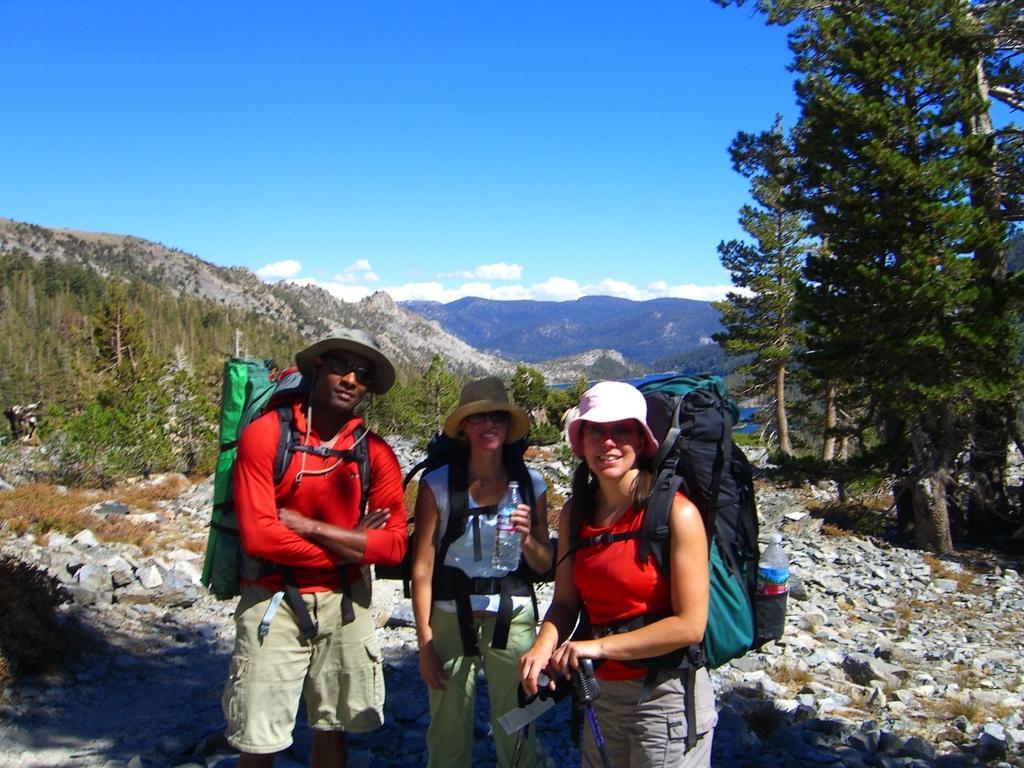In one or two sentences, can you explain what this image depicts? In this image we can see three people standing with their backpacks on the ground. In the background we can see mountains, clouds, sky and trees. 